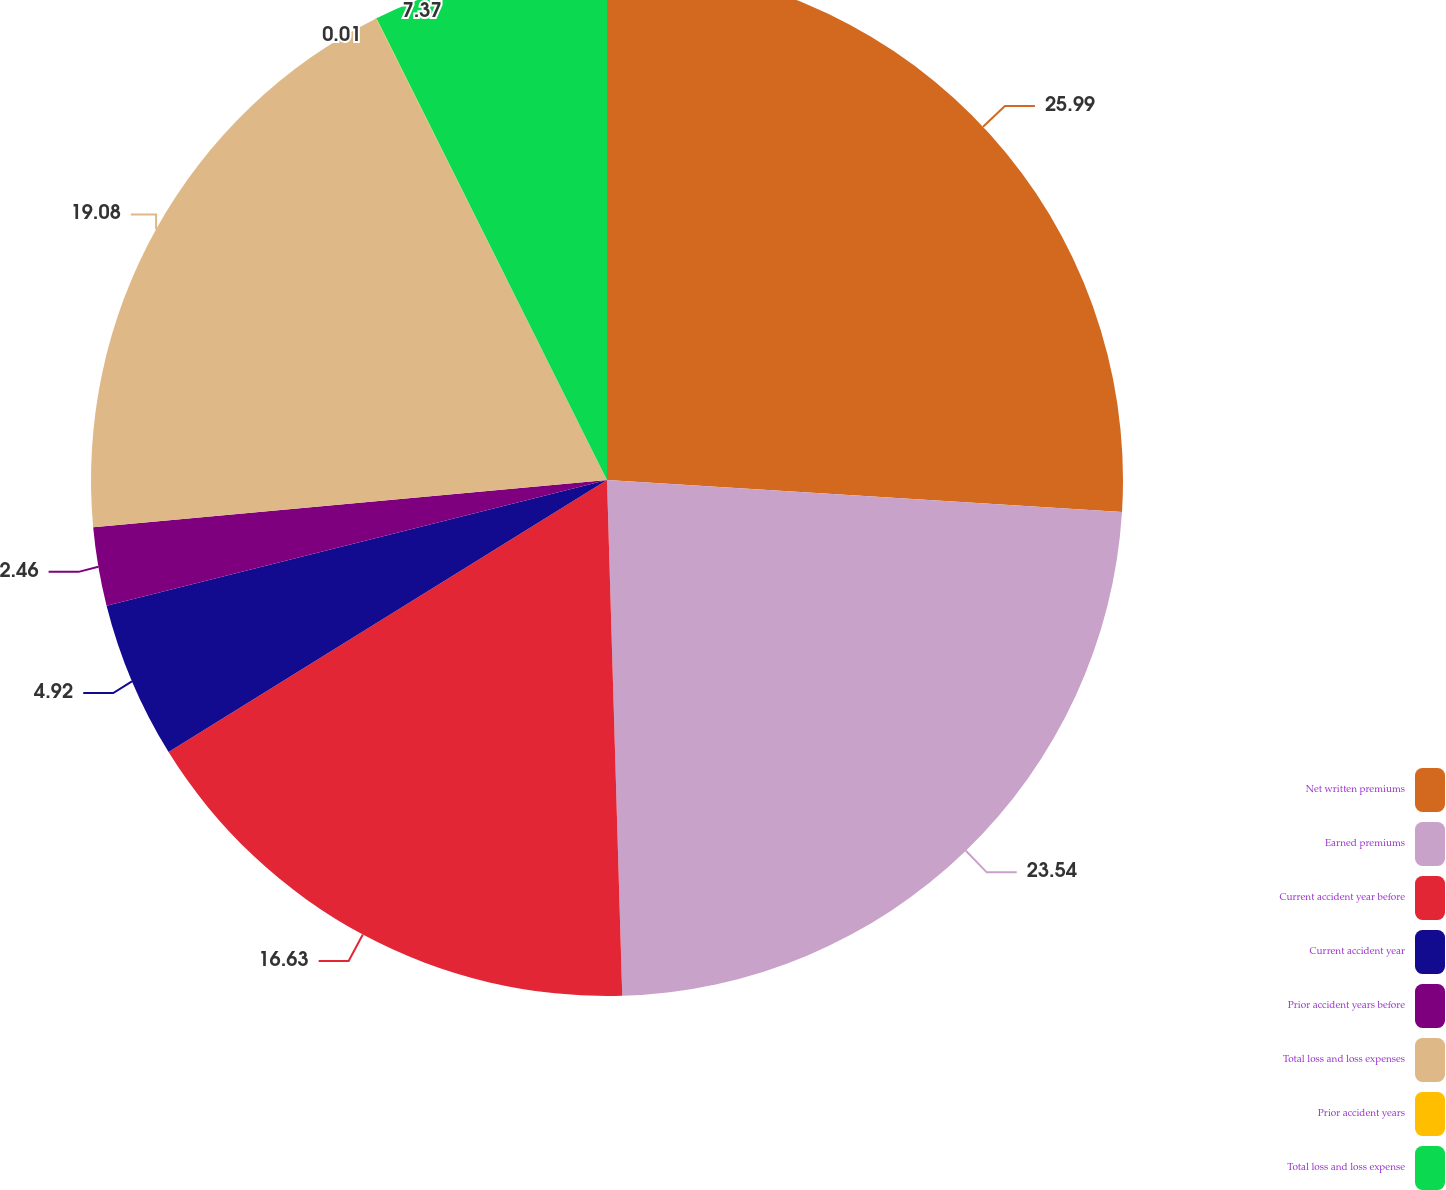Convert chart to OTSL. <chart><loc_0><loc_0><loc_500><loc_500><pie_chart><fcel>Net written premiums<fcel>Earned premiums<fcel>Current accident year before<fcel>Current accident year<fcel>Prior accident years before<fcel>Total loss and loss expenses<fcel>Prior accident years<fcel>Total loss and loss expense<nl><fcel>25.99%<fcel>23.54%<fcel>16.63%<fcel>4.92%<fcel>2.46%<fcel>19.08%<fcel>0.01%<fcel>7.37%<nl></chart> 